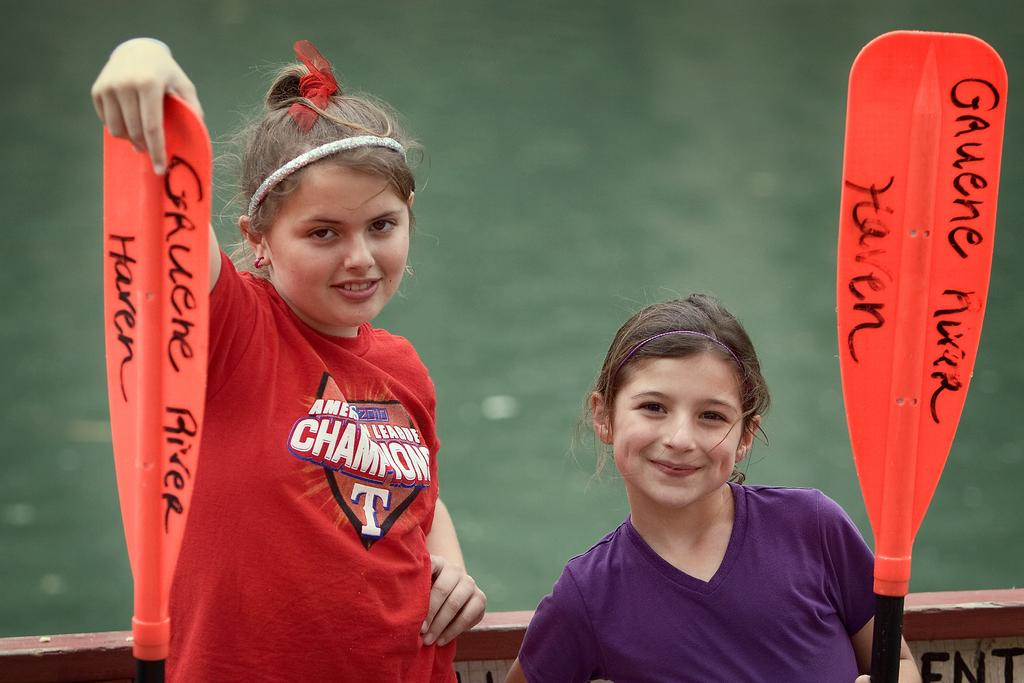<image>
Present a compact description of the photo's key features. two little girls with oars that say gruene river haven 